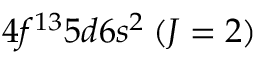<formula> <loc_0><loc_0><loc_500><loc_500>4 f ^ { 1 3 } 5 d 6 s ^ { 2 } \, ( J = 2 )</formula> 